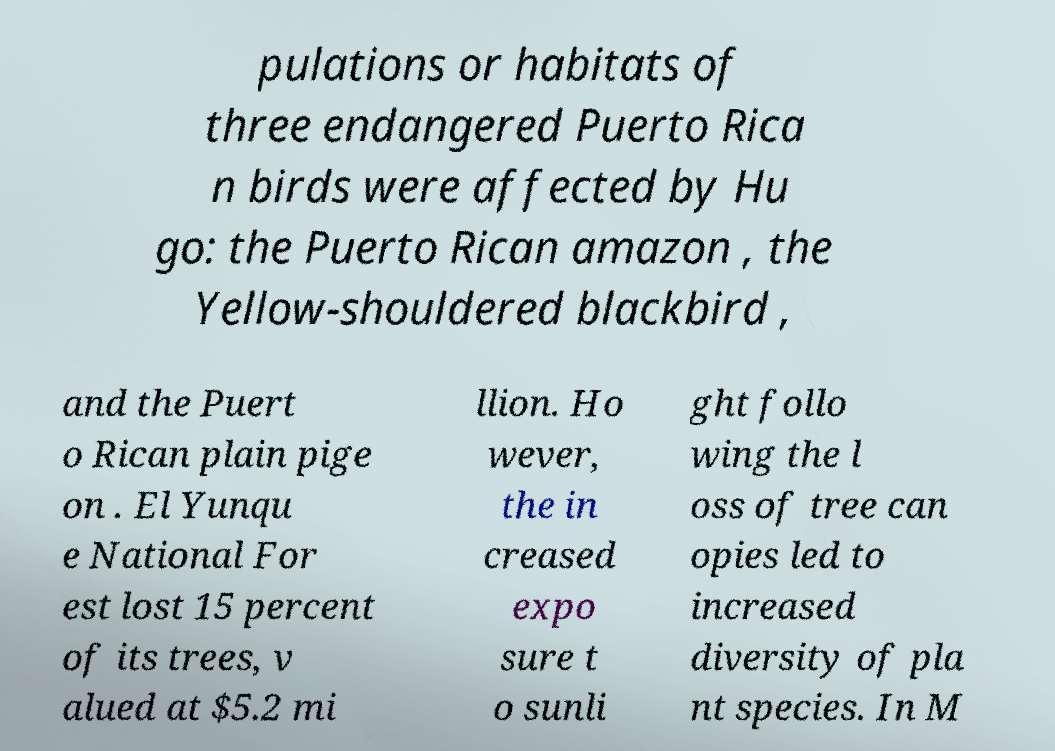There's text embedded in this image that I need extracted. Can you transcribe it verbatim? pulations or habitats of three endangered Puerto Rica n birds were affected by Hu go: the Puerto Rican amazon , the Yellow-shouldered blackbird , and the Puert o Rican plain pige on . El Yunqu e National For est lost 15 percent of its trees, v alued at $5.2 mi llion. Ho wever, the in creased expo sure t o sunli ght follo wing the l oss of tree can opies led to increased diversity of pla nt species. In M 